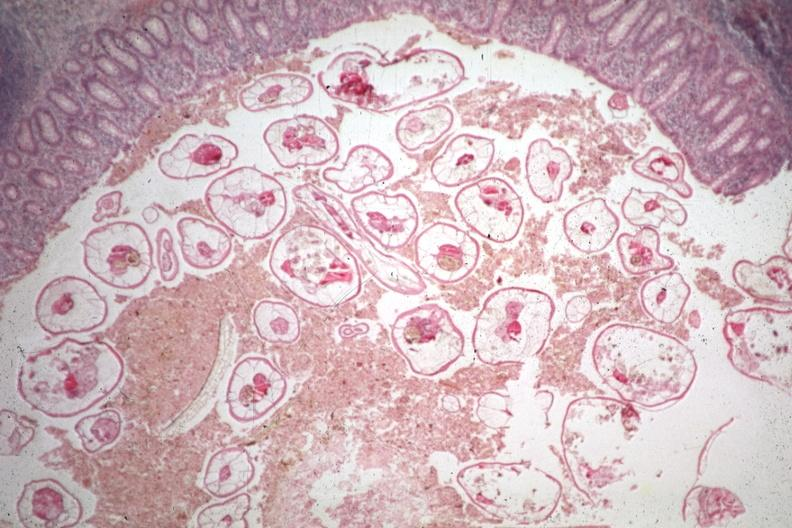s myocardium present?
Answer the question using a single word or phrase. No 